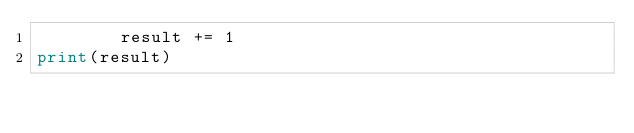<code> <loc_0><loc_0><loc_500><loc_500><_Python_>        result += 1
print(result)
</code> 